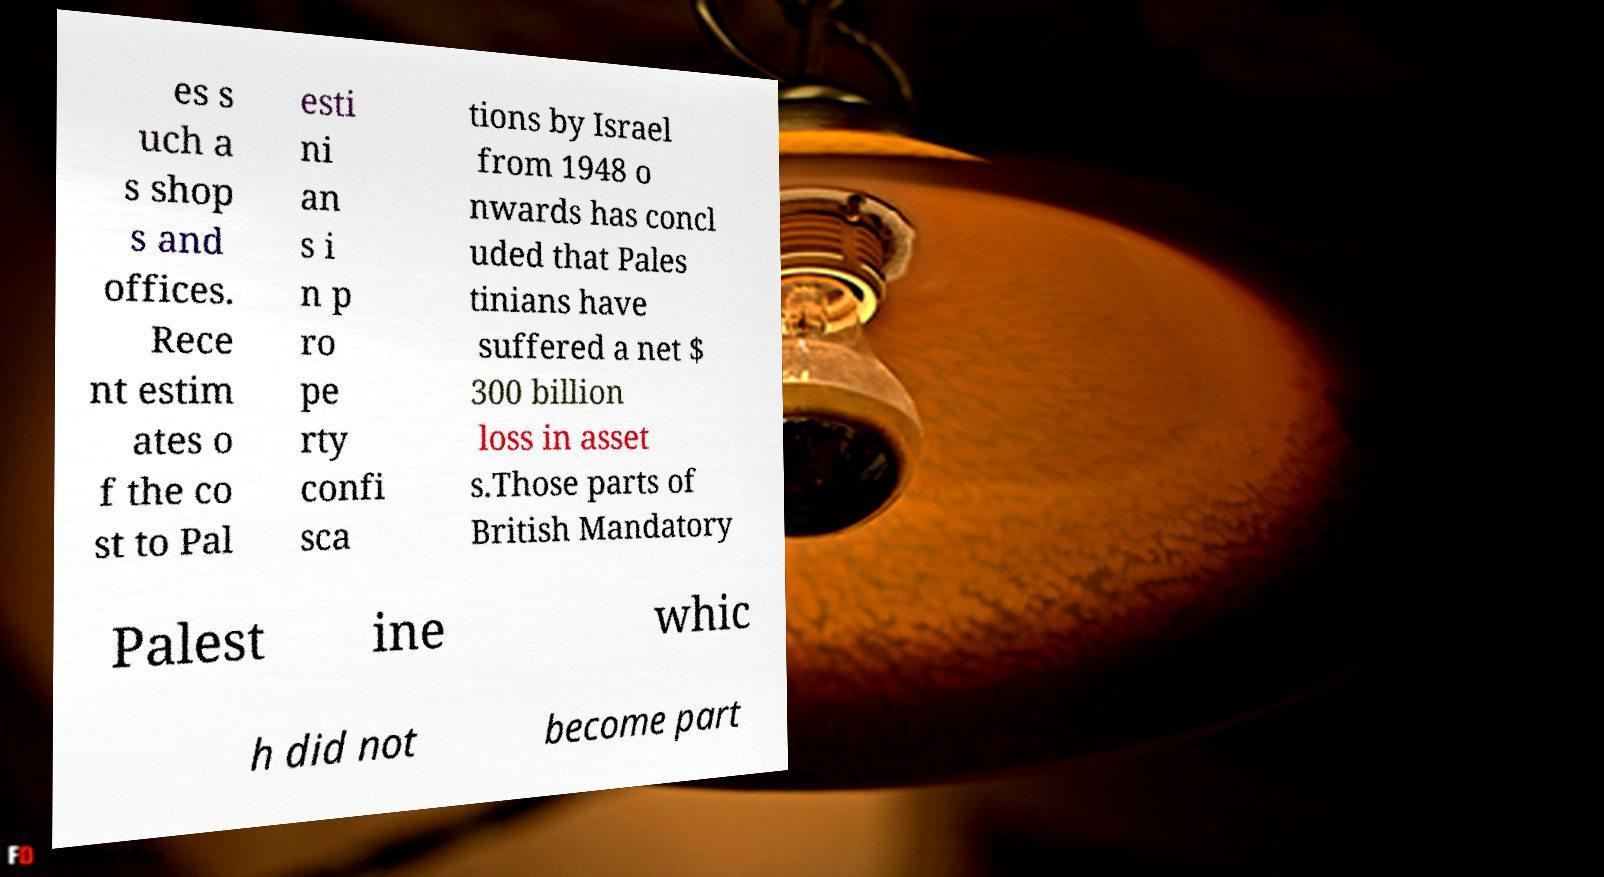Could you assist in decoding the text presented in this image and type it out clearly? es s uch a s shop s and offices. Rece nt estim ates o f the co st to Pal esti ni an s i n p ro pe rty confi sca tions by Israel from 1948 o nwards has concl uded that Pales tinians have suffered a net $ 300 billion loss in asset s.Those parts of British Mandatory Palest ine whic h did not become part 